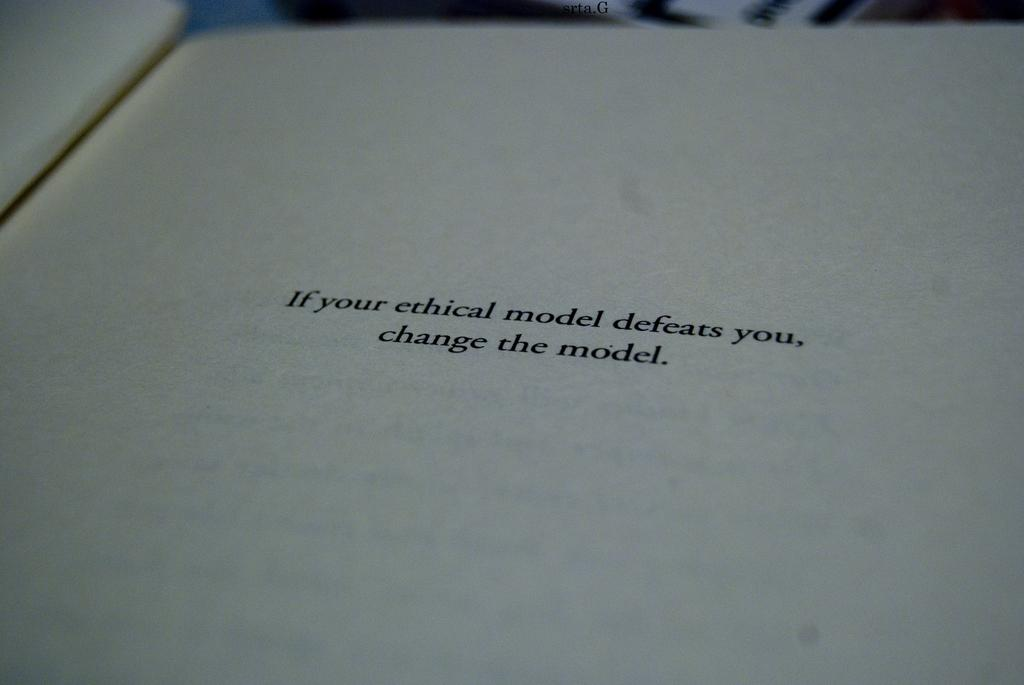<image>
Give a short and clear explanation of the subsequent image. A quote about ethical models is shown on a page in an open book. 